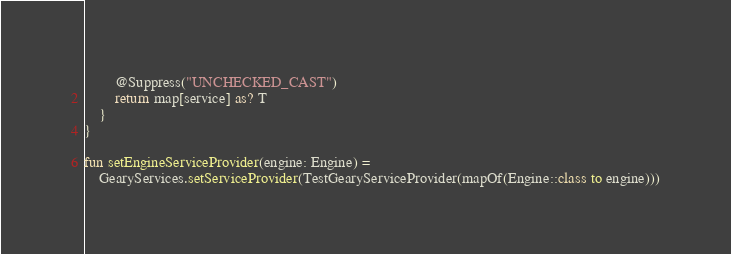<code> <loc_0><loc_0><loc_500><loc_500><_Kotlin_>        @Suppress("UNCHECKED_CAST")
        return map[service] as? T
    }
}

fun setEngineServiceProvider(engine: Engine) =
    GearyServices.setServiceProvider(TestGearyServiceProvider(mapOf(Engine::class to engine)))
</code> 